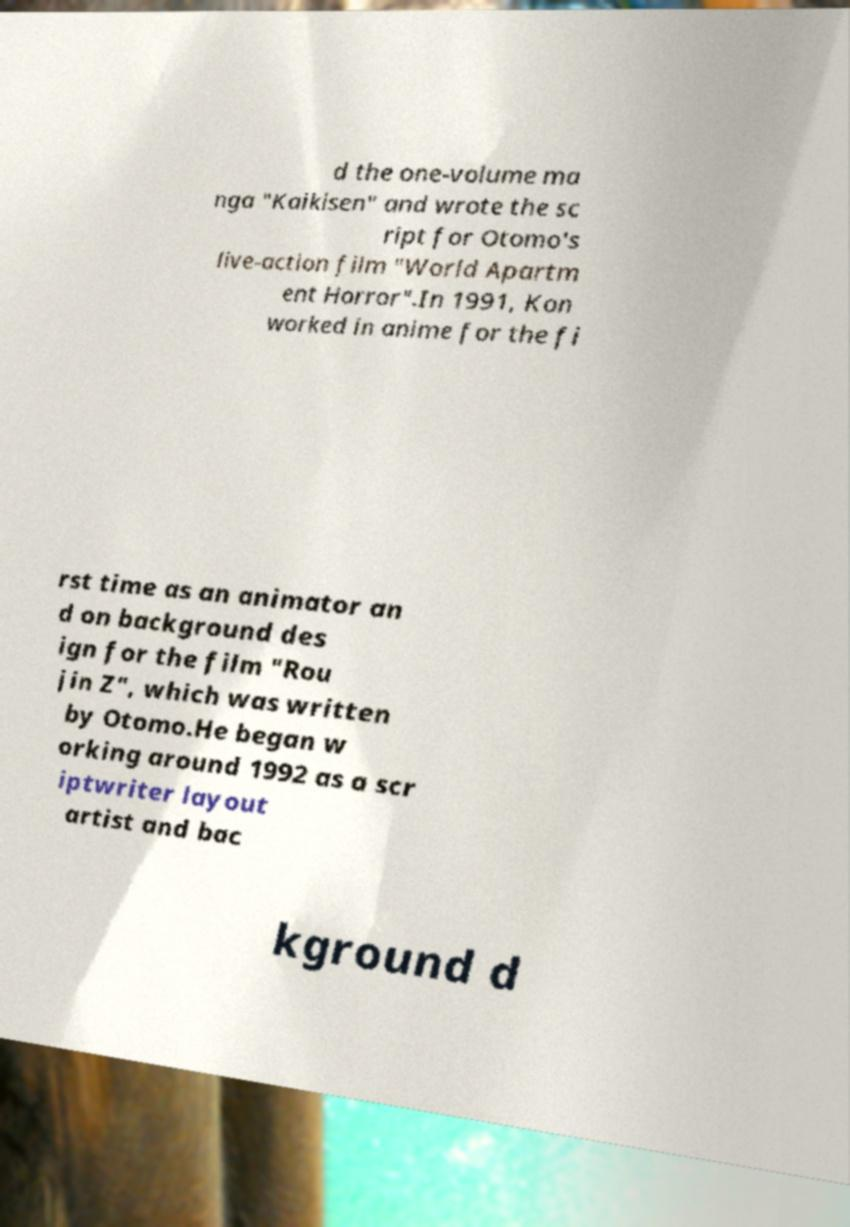Could you extract and type out the text from this image? d the one-volume ma nga "Kaikisen" and wrote the sc ript for Otomo's live-action film "World Apartm ent Horror".In 1991, Kon worked in anime for the fi rst time as an animator an d on background des ign for the film "Rou jin Z", which was written by Otomo.He began w orking around 1992 as a scr iptwriter layout artist and bac kground d 